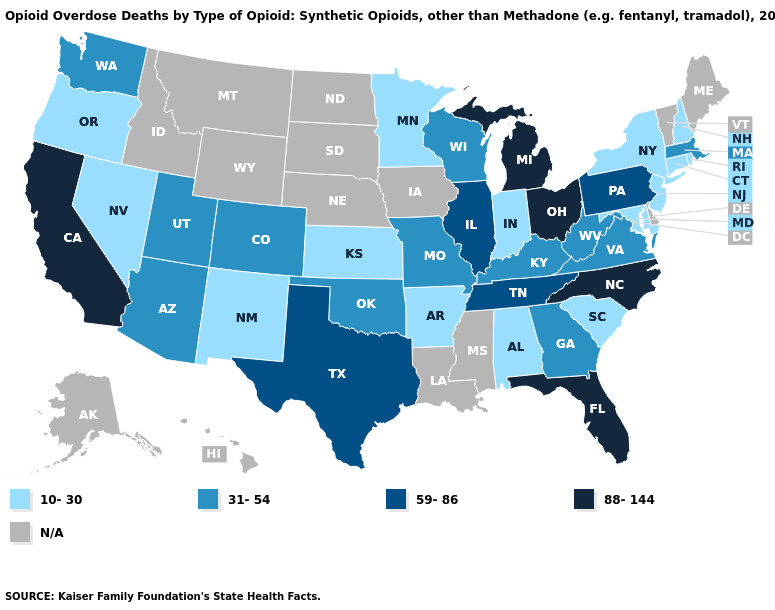Name the states that have a value in the range 10-30?
Be succinct. Alabama, Arkansas, Connecticut, Indiana, Kansas, Maryland, Minnesota, Nevada, New Hampshire, New Jersey, New Mexico, New York, Oregon, Rhode Island, South Carolina. Name the states that have a value in the range 10-30?
Give a very brief answer. Alabama, Arkansas, Connecticut, Indiana, Kansas, Maryland, Minnesota, Nevada, New Hampshire, New Jersey, New Mexico, New York, Oregon, Rhode Island, South Carolina. How many symbols are there in the legend?
Be succinct. 5. What is the highest value in the South ?
Be succinct. 88-144. What is the value of Texas?
Answer briefly. 59-86. Name the states that have a value in the range 31-54?
Short answer required. Arizona, Colorado, Georgia, Kentucky, Massachusetts, Missouri, Oklahoma, Utah, Virginia, Washington, West Virginia, Wisconsin. Which states have the highest value in the USA?
Answer briefly. California, Florida, Michigan, North Carolina, Ohio. Name the states that have a value in the range N/A?
Short answer required. Alaska, Delaware, Hawaii, Idaho, Iowa, Louisiana, Maine, Mississippi, Montana, Nebraska, North Dakota, South Dakota, Vermont, Wyoming. Does Rhode Island have the lowest value in the USA?
Short answer required. Yes. Among the states that border North Carolina , does Tennessee have the highest value?
Short answer required. Yes. Which states hav the highest value in the Northeast?
Give a very brief answer. Pennsylvania. Name the states that have a value in the range 88-144?
Answer briefly. California, Florida, Michigan, North Carolina, Ohio. 